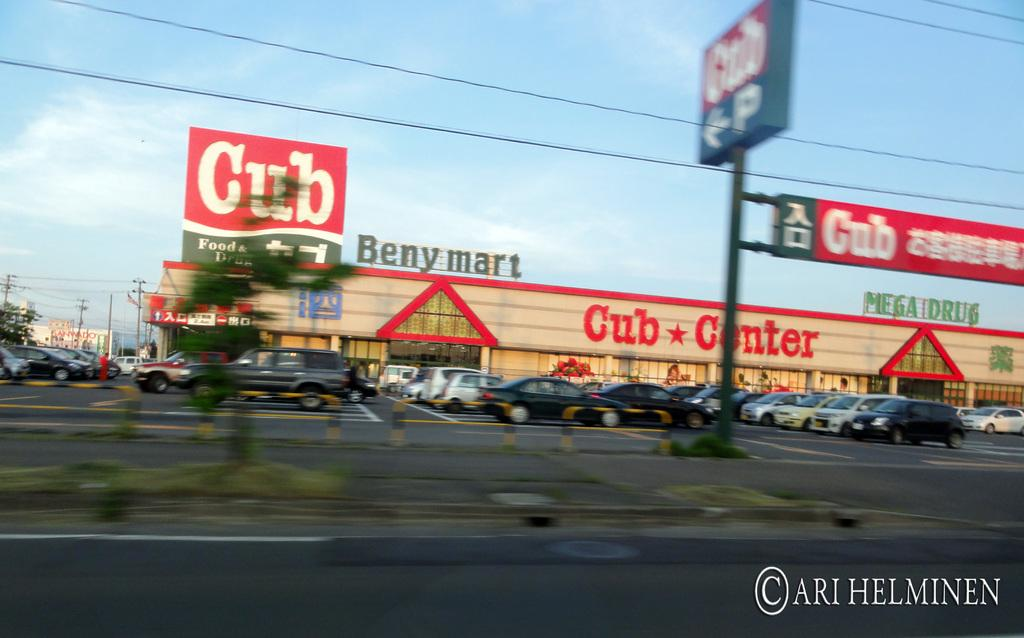<image>
Describe the image concisely. A Cub Center store with a parking lot full of cars 